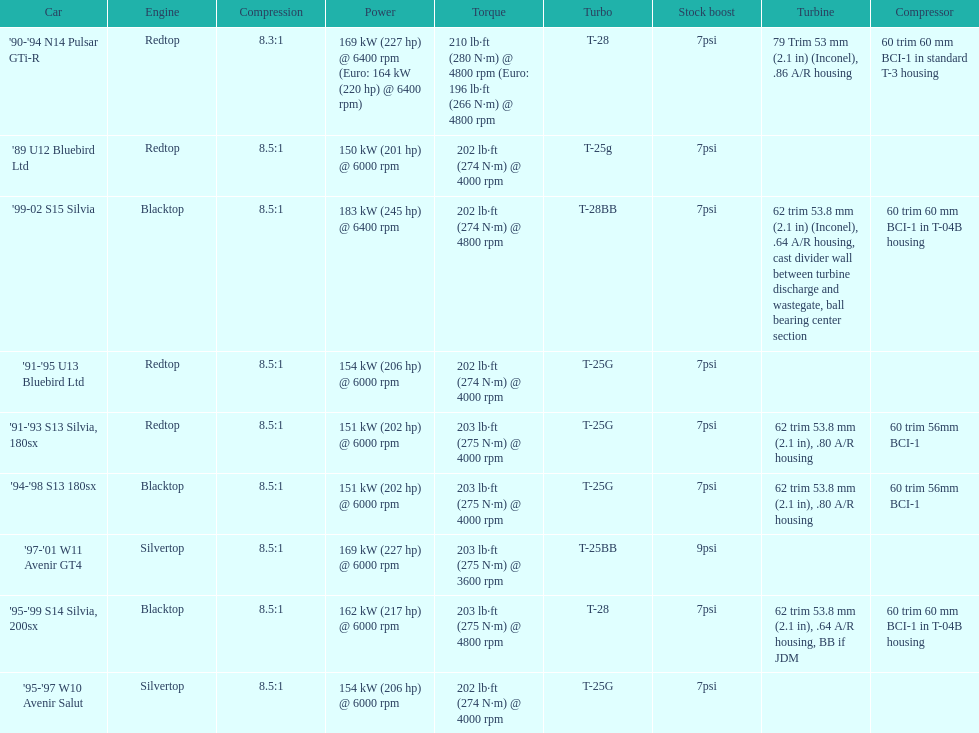Which engines are the same as the first entry ('89 u12 bluebird ltd)? '91-'95 U13 Bluebird Ltd, '90-'94 N14 Pulsar GTi-R, '91-'93 S13 Silvia, 180sx. 